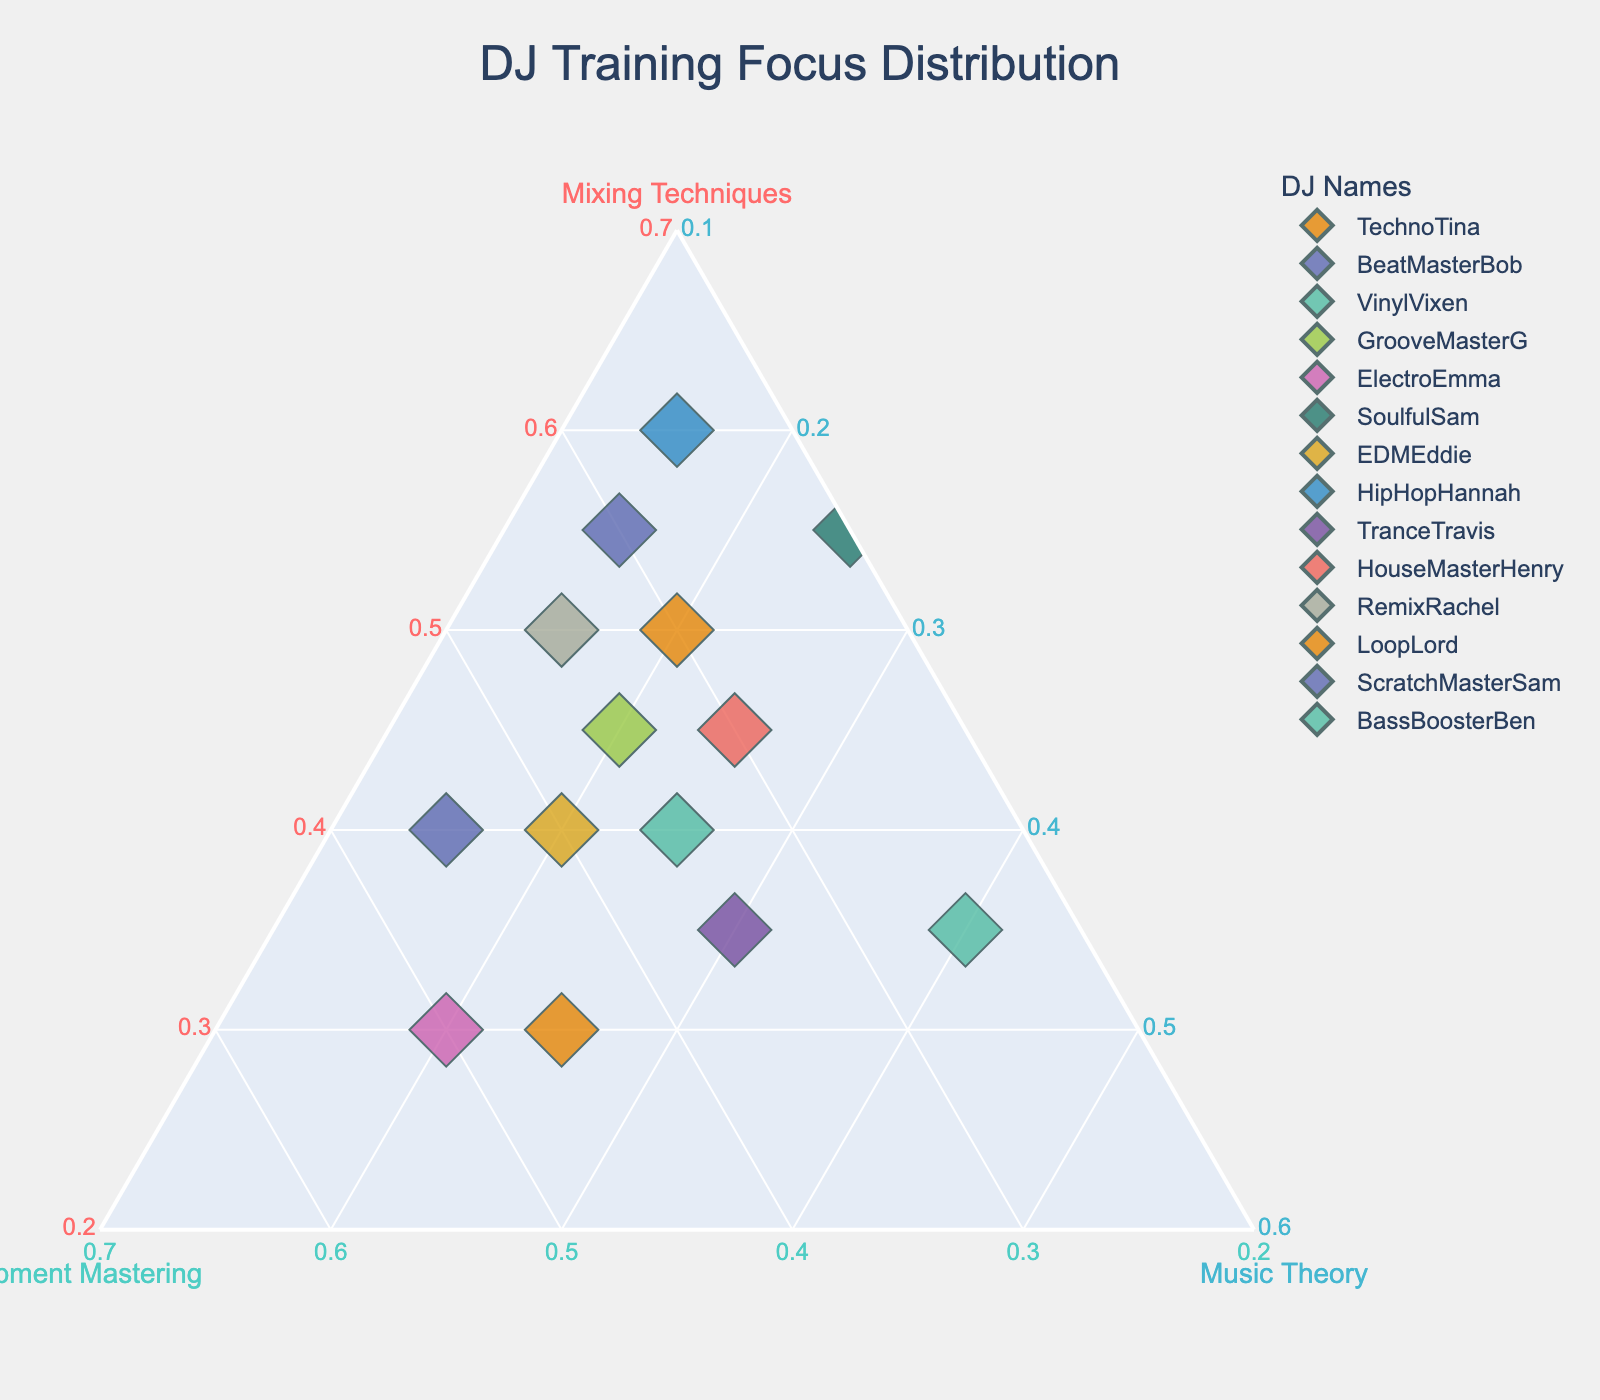What is the title of the ternary plot? The title of the plot is usually displayed at the top of the plot. In this case, it is clearly mentioned
Answer: DJ Training Focus Distribution Which axis represents the percentage of time spent on Equipment Mastering? The label on the side of the plot that indicates this information will be available directly on the figure. Here, it is the axis named "Equipment Mastering"
Answer: Equipment Mastering Who spent the highest percentage of time on Music Theory? By looking at the vertex close to the Music Theory label and finding the data point closest to that corner, you can identify the DJ. In this case, it's VinylVixen
Answer: VinylVixen Which DJ names are involved in the ternary plot? By examining the legend on the figure, which lists the DJ names represented by different colors, the names can be seen.
Answer: TechnoTina, BeatMasterBob, VinylVixen, GrooveMasterG, ElectroEmma, SoulfulSam, EDMEddie, HipHopHannah, TranceTravis, HouseMasterHenry, RemixRachel, LoopLord, ScratchMasterSam, BassBoosterBen How many DJs are plotted in the figure? Count the number of data points or the entries in the legend
Answer: 14 Which DJ has the most balanced distribution of time among Mixing Techniques, Equipment Mastering, and Music Theory? The DJ with the most balanced distribution will be closest to the center of the plot, where the three components are nearly equal
Answer: TranceTravis Is there a DJ who spent exactly equal time on Mixing Techniques and Equipment Mastering? Look for a point along the line that equally divides the Mixing Techniques and Equipment Mastering axes. This line would split the bottom area diagonally
Answer: None Which two DJs spent the same ratio of time on Equipment Mastering and Music Theory? Compare the relative positions of the data points along the line parallel to the b and c axes that defines their ratio. It involves matching the locations with the legends
Answer: EDMEddie and HouseMasterHenry Who spent the least percentage of time on Mixing Techniques? Locate the data point closest to the vertex of the Equipment Mastering or Music Theory axis and identify the DJ name
Answer: ElectroEmma and LoopLord spend the least percentage on Mixing Techniques with 30% What is the average percentage of time spent on Music Theory by all DJs? Sum all the percentages for Music Theory and divide by the number of DJs (20+15+40+20+20+25+20+15+30+25+15+25+15+25). This equals 310/14 = 22.14%
Answer: 22.14% 